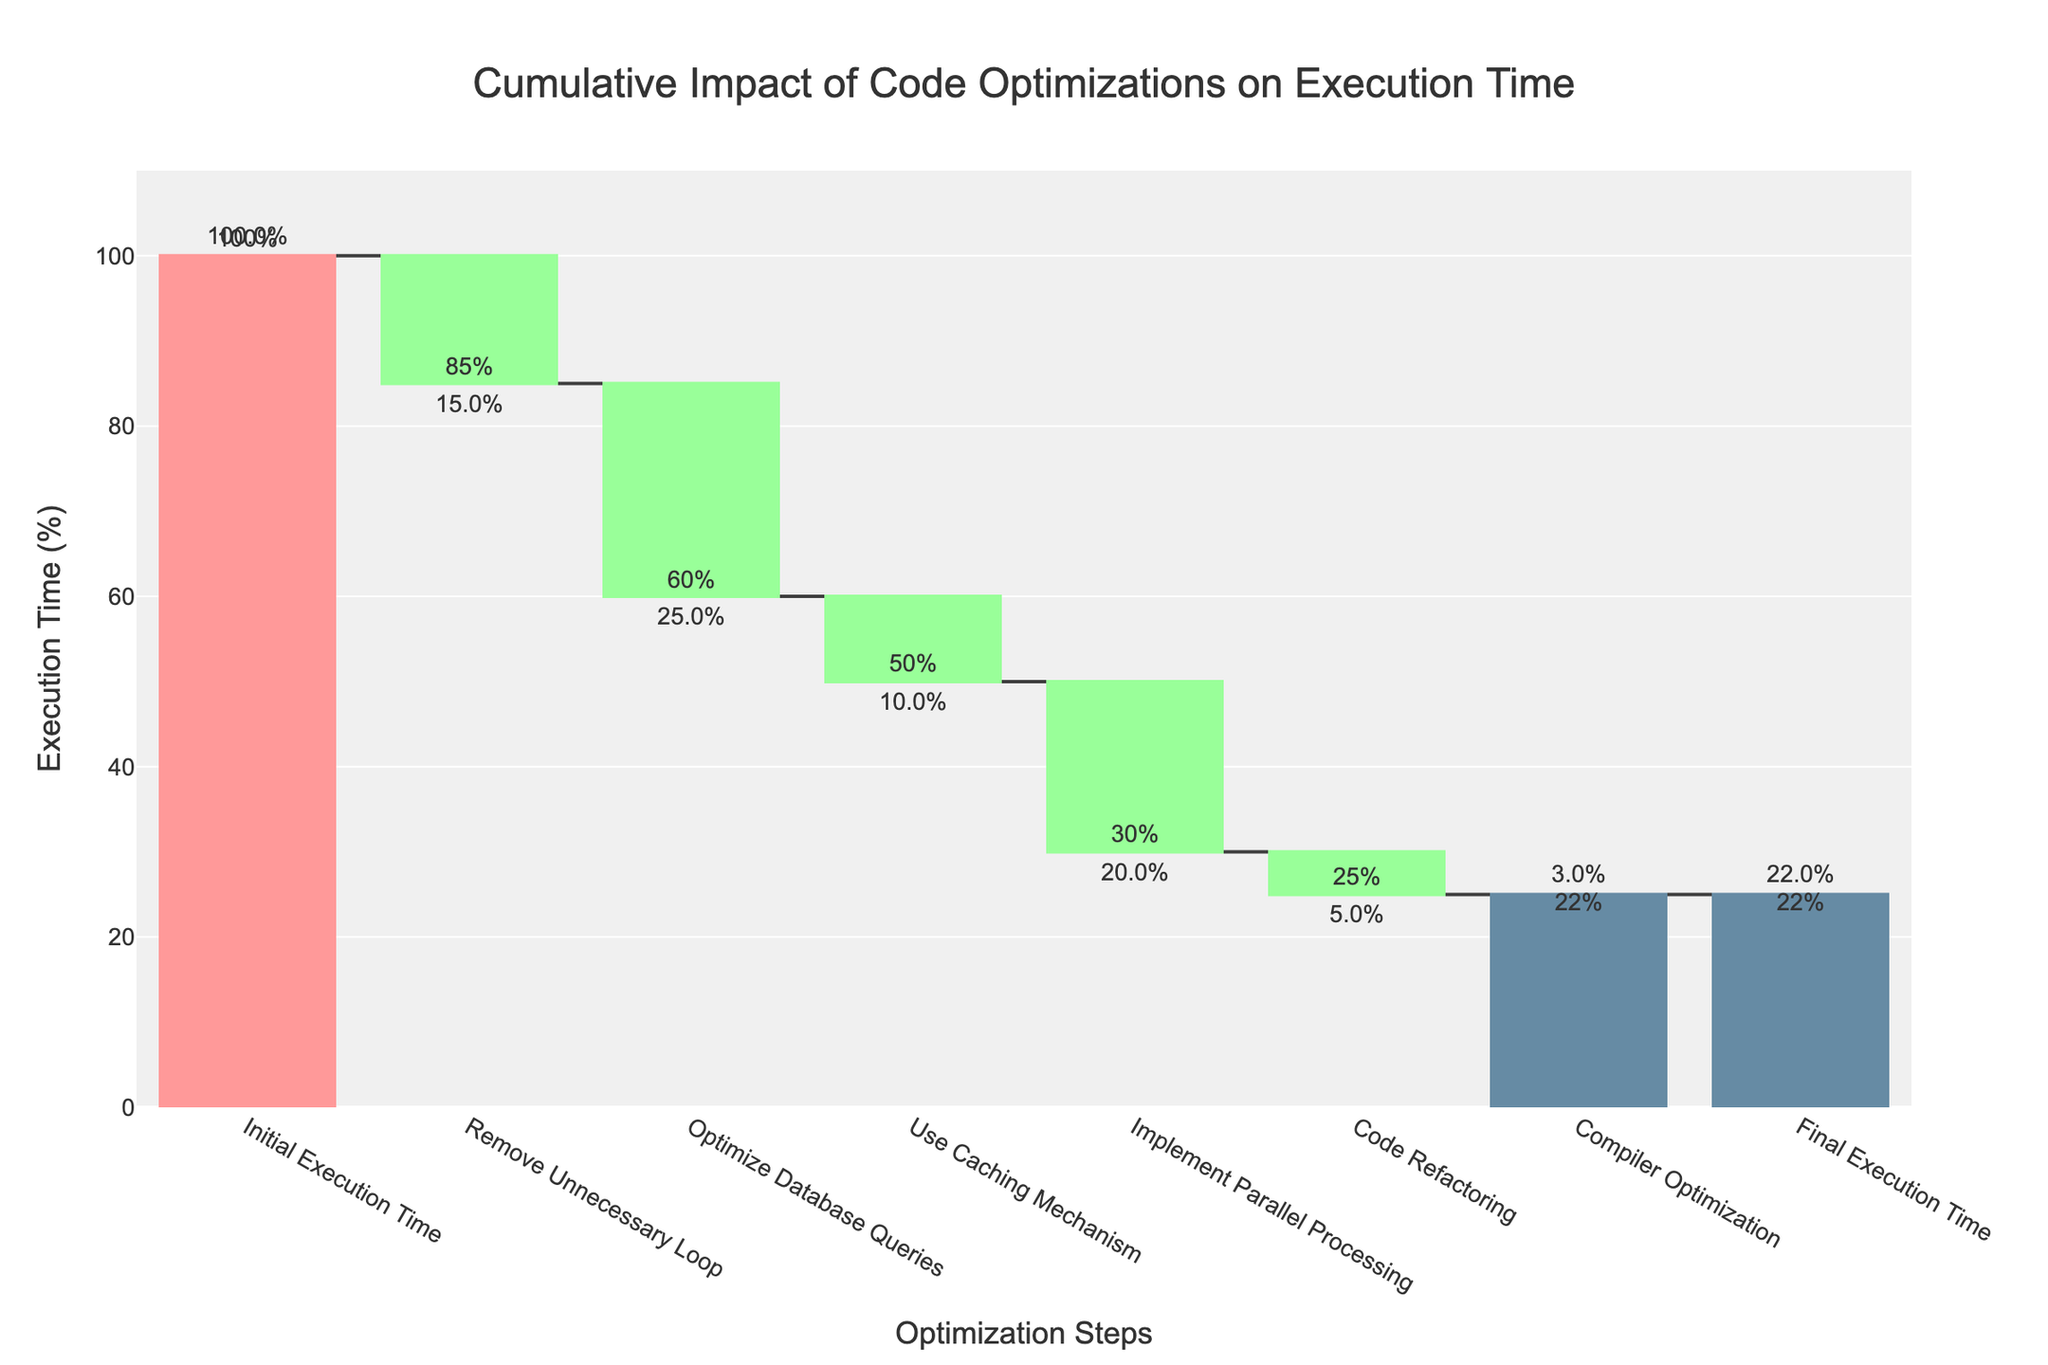What is the title of the chart? The title is located at the top of the chart, displayed prominently with larger font for emphasis.
Answer: Cumulative Impact of Code Optimizations on Execution Time What is the initial execution time in the chart? The initial execution time is the first entry on the x-axis. The corresponding value from the 'Value' column indicates it.
Answer: 100% How many optimization steps are there before reaching the final execution time? Excluding the initial and final times, count the number of steps in between on the x-axis.
Answer: 6 By how much percent does the "Remove Unnecessary Loop" step reduce the execution time? Look for the "Remove Unnecessary Loop" step on the x-axis and refer to the corresponding impact value.
Answer: 15% What is the cumulative reduction in execution time after optimizing database queries and using a caching mechanism? The optimization after these two steps are cumulative, so sum their impacts: -25 (Optimize Database Queries) + -10 (Use Caching Mechanism).
Answer: 35% Compare the impact of "Optimize Database Queries" and "Use Caching Mechanism." Which has a greater impact? Compare the impact values of these two steps.
Answer: Optimize Database Queries By how much does "Implement Parallel Processing" reduce the execution time compared to the "Code Refactoring" step? Subtract the impact value of "Code Refactoring" from "Implement Parallel Processing": -20 - (-5).
Answer: 15% What is the percentage decrease in execution time from the initial to the final value? Subtract the final execution time from the initial and then find the percentage decrease: (100 - 22) / 100 * 100.
Answer: 78% Which optimization step has the smallest impact on reducing execution time? Identify the step with the smallest negative impact value.
Answer: Compiler Optimization What is the final execution time shown on the chart after all optimizations are applied? The final execution time is the last entry on the x-axis. The corresponding value from the 'Value' column indicates it.
Answer: 22% 